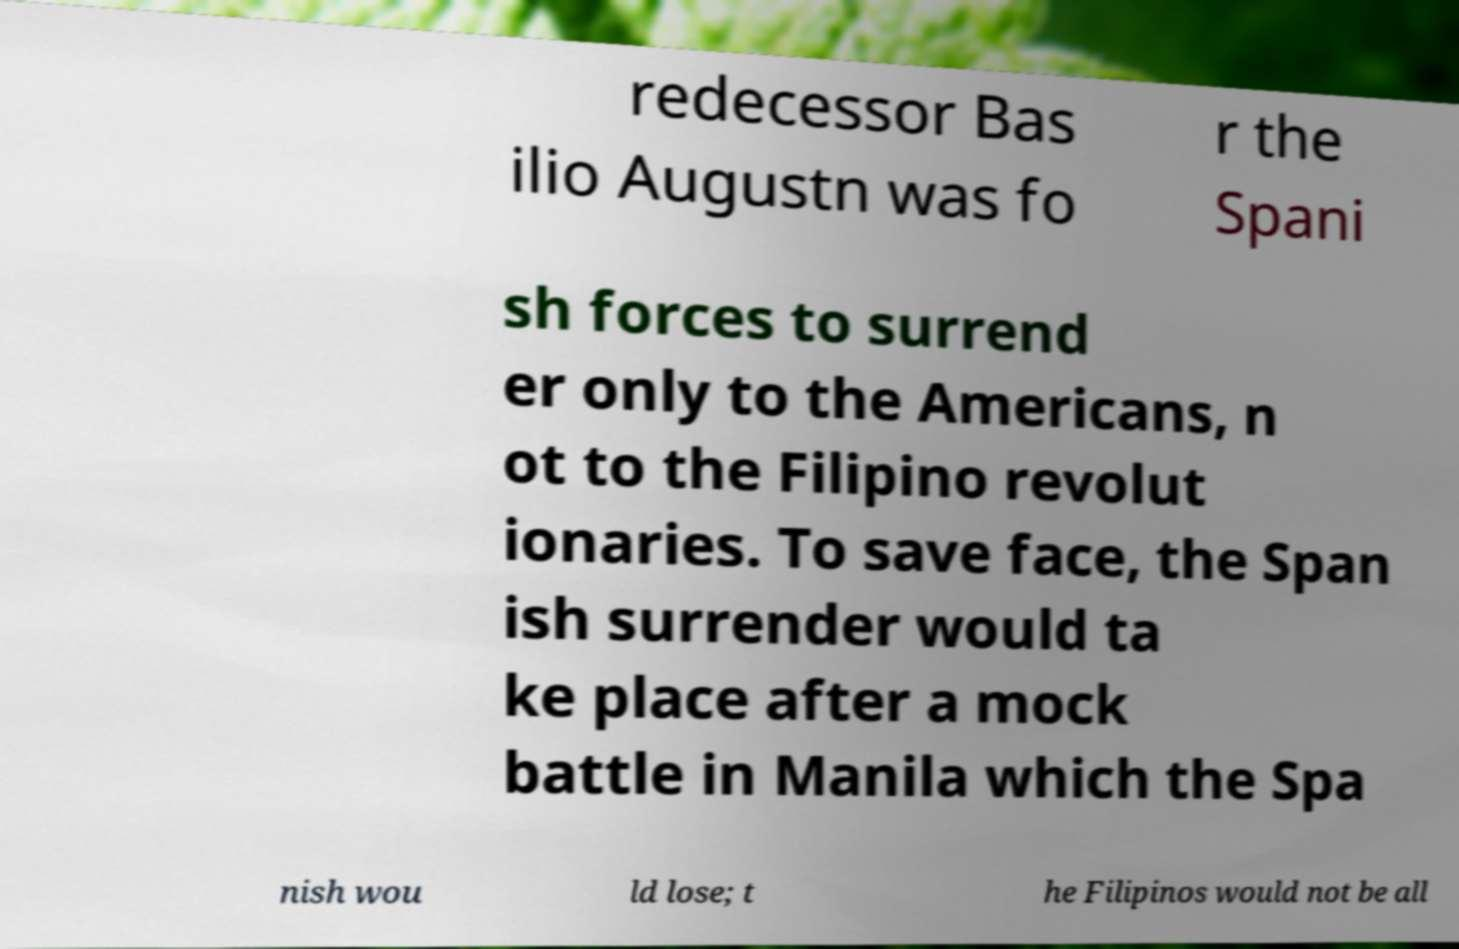There's text embedded in this image that I need extracted. Can you transcribe it verbatim? redecessor Bas ilio Augustn was fo r the Spani sh forces to surrend er only to the Americans, n ot to the Filipino revolut ionaries. To save face, the Span ish surrender would ta ke place after a mock battle in Manila which the Spa nish wou ld lose; t he Filipinos would not be all 